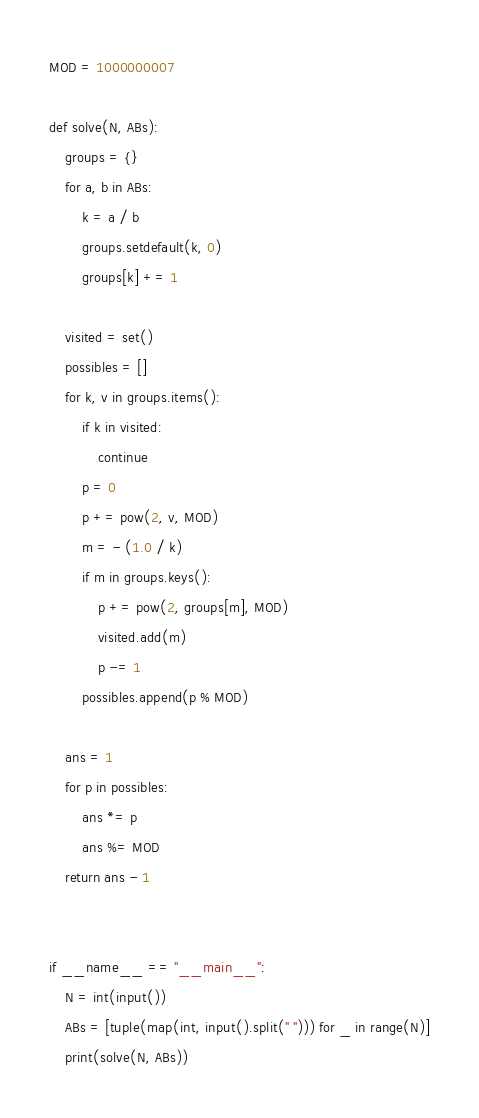Convert code to text. <code><loc_0><loc_0><loc_500><loc_500><_Python_>MOD = 1000000007

def solve(N, ABs):
    groups = {}
    for a, b in ABs:
        k = a / b
        groups.setdefault(k, 0)
        groups[k] += 1

    visited = set()
    possibles = []
    for k, v in groups.items():
        if k in visited:
            continue
        p = 0
        p += pow(2, v, MOD)
        m = - (1.0 / k)
        if m in groups.keys():
            p += pow(2, groups[m], MOD)
            visited.add(m)
            p -= 1
        possibles.append(p % MOD)

    ans = 1
    for p in possibles:
        ans *= p
        ans %= MOD
    return ans - 1


if __name__ == "__main__":
    N = int(input())
    ABs = [tuple(map(int, input().split(" "))) for _ in range(N)]
    print(solve(N, ABs))
</code> 